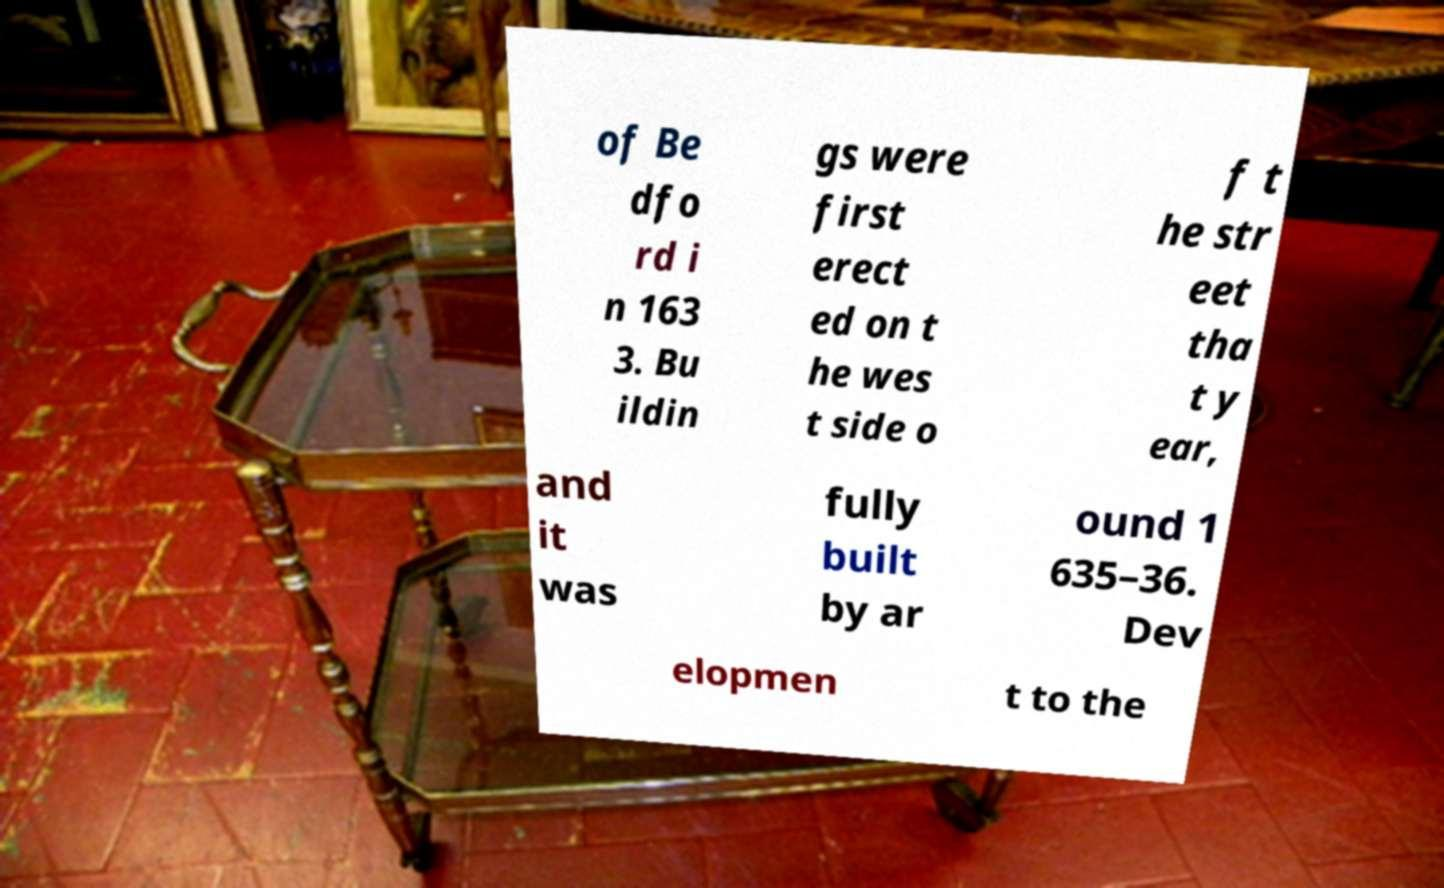Can you accurately transcribe the text from the provided image for me? of Be dfo rd i n 163 3. Bu ildin gs were first erect ed on t he wes t side o f t he str eet tha t y ear, and it was fully built by ar ound 1 635–36. Dev elopmen t to the 